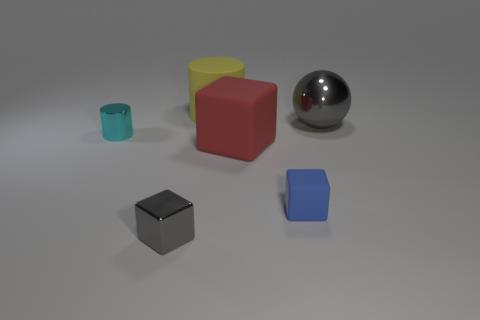Subtract all red rubber cubes. How many cubes are left? 2 Subtract all cyan cylinders. How many cylinders are left? 1 Add 4 large shiny objects. How many objects exist? 10 Subtract all cylinders. How many objects are left? 4 Subtract 1 cubes. How many cubes are left? 2 Subtract 0 brown balls. How many objects are left? 6 Subtract all red cubes. Subtract all green balls. How many cubes are left? 2 Subtract all yellow objects. Subtract all large yellow objects. How many objects are left? 4 Add 4 big red rubber objects. How many big red rubber objects are left? 5 Add 5 small gray shiny cubes. How many small gray shiny cubes exist? 6 